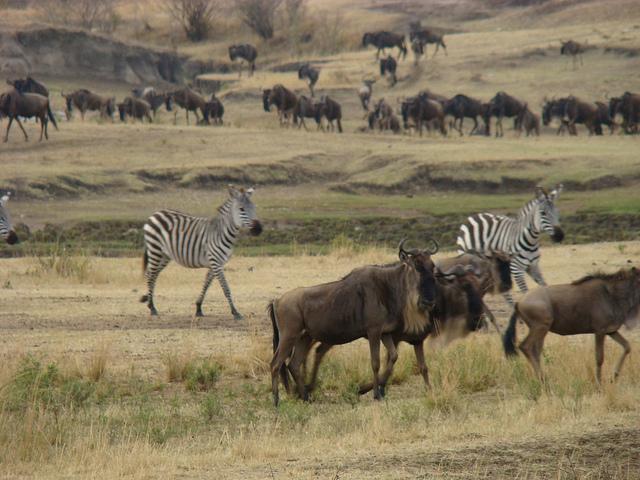Are the animals fighting?
Be succinct. No. How many animals are shown?
Give a very brief answer. 5. Are they in these animals in their natural environment?
Be succinct. Yes. What types of animals are in the field?
Give a very brief answer. Zebras. 